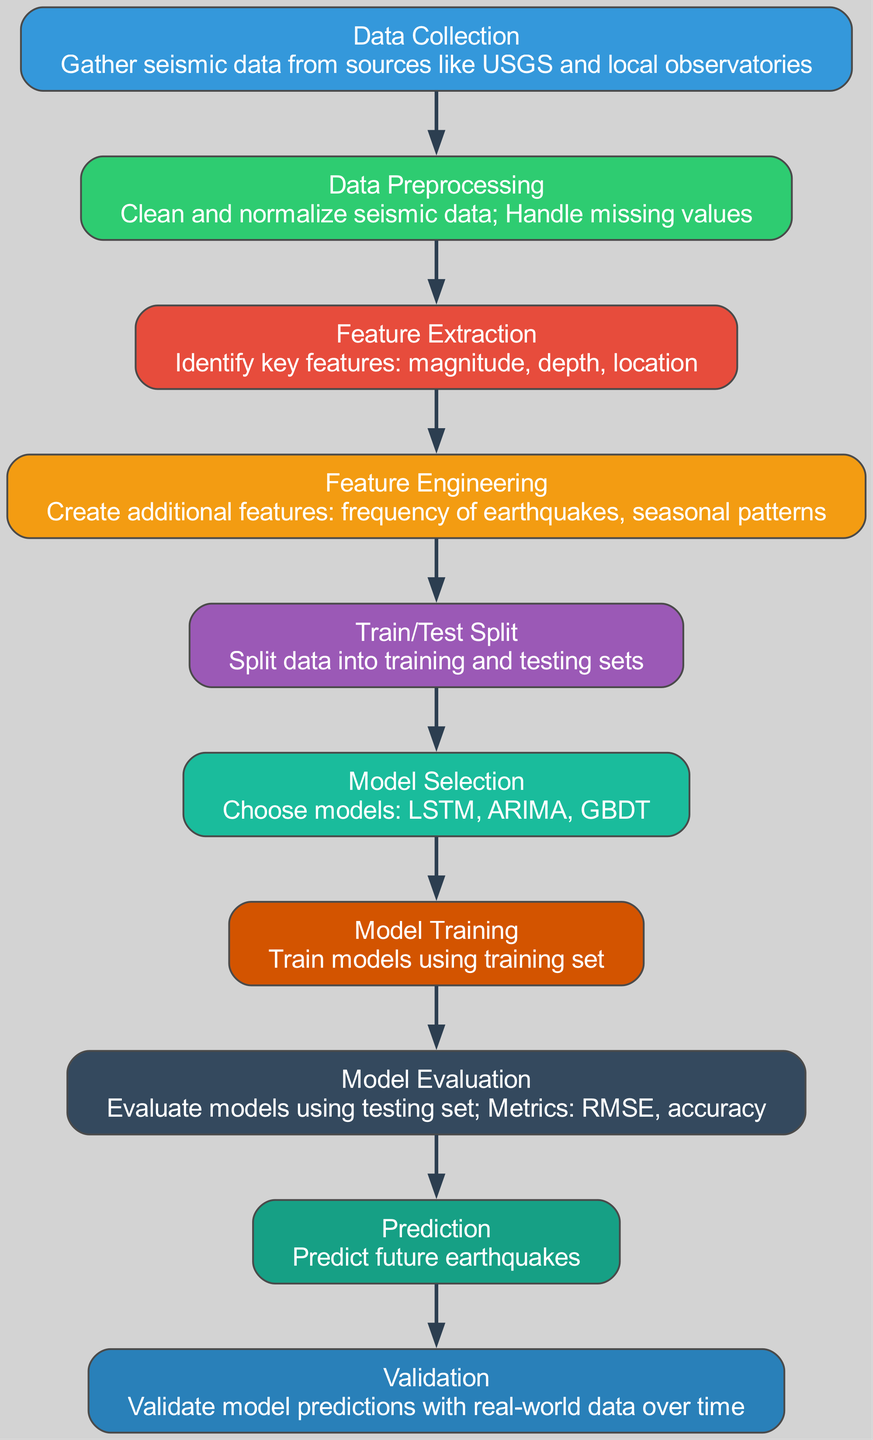What is the first step in the process? The process begins with the "Data Collection" node, which involves gathering seismic data from various sources. This node is positioned at the top of the flow, indicating it is the initial step before any other processes occur.
Answer: Data Collection How many nodes are there in total? By counting each labeled section in the diagram, we can determine that there are ten distinct nodes representing different stages of the earthquake prediction process.
Answer: Ten What do the arrows in the diagram represent? The arrows indicate the flow of processes, showing the relationship and sequence between each step involved in predicting earthquake occurrences. They direct from one node to the next, illustrating progression.
Answer: Flow of processes Which model is selected after the data is split? After the "Train/Test Split" node is completed, the next step is "Model Selection," where different models such as LSTM, ARIMA, and GBDT are chosen for training. This sequential flow indicates the selection process follows the data preparation stage.
Answer: Model Selection What is the purpose of the "Model Evaluation" step? The "Model Evaluation" node's purpose is to assess the performance of the selected models using metrics like RMSE and accuracy on the testing set, ensuring that the models are effective for predictions. This evaluation is critical for determining the reliability of the model outputs.
Answer: Assess performance What types of features are created during "Feature Engineering"? During "Feature Engineering," additional features are created, including the frequency of earthquakes and seasonal patterns, which help in improving predictive accuracy and model performance. This step builds upon the identified key features extracted earlier.
Answer: Frequency and seasonal patterns What is the final step in the workflow? The last node in the workflow is "Validation," where model predictions are validated using real-world data over time, ensuring the predictions align with actual seismic events. This step confirms the models’ overall effectiveness post-prediction.
Answer: Validation Which models are included in the "Model Selection" phase? The "Model Selection" phase explicitly mentions LSTM, ARIMA, and GBDT as the choices available for predicting earthquake occurrences, illustrating the variety of methodologies that can be applied in this context.
Answer: LSTM, ARIMA, GBDT How does "Feature Extraction" relate to "Data Preprocessing"? "Feature Extraction" follows "Data Preprocessing," signifying that before key features are identified, the seismic data must first be cleaned and normalized. This relationship shows that preprocessing is foundational for effective feature extraction.
Answer: It follows and builds upon it 